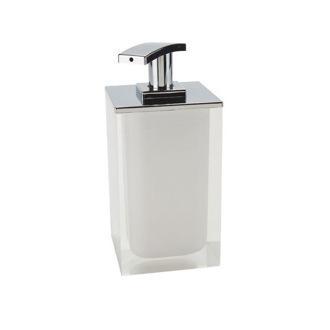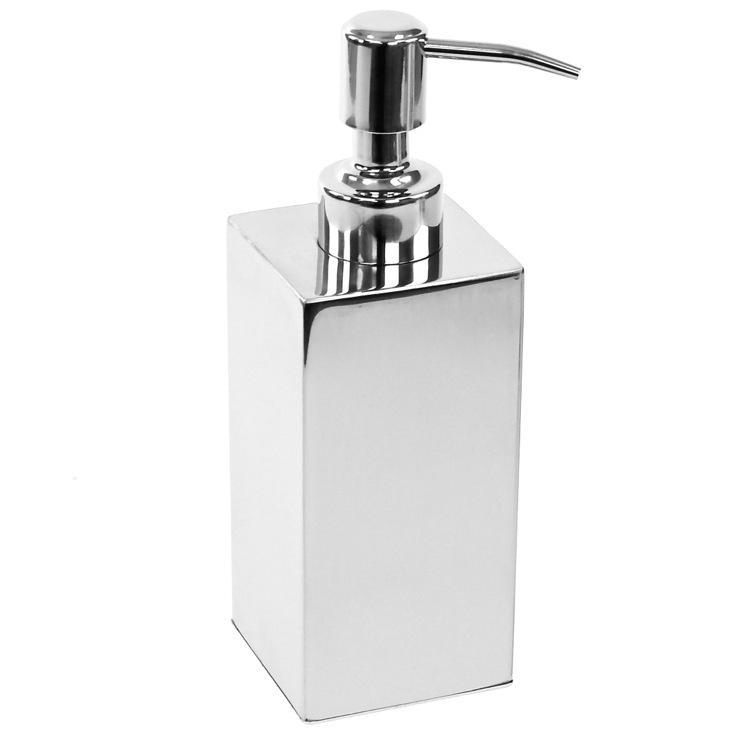The first image is the image on the left, the second image is the image on the right. Given the left and right images, does the statement "The rectangular dispenser on the left is taller than the white dispenser on the right." hold true? Answer yes or no. No. The first image is the image on the left, the second image is the image on the right. Given the left and right images, does the statement "The nozzles of the dispensers in the left and right images face generally away from each other." hold true? Answer yes or no. Yes. 